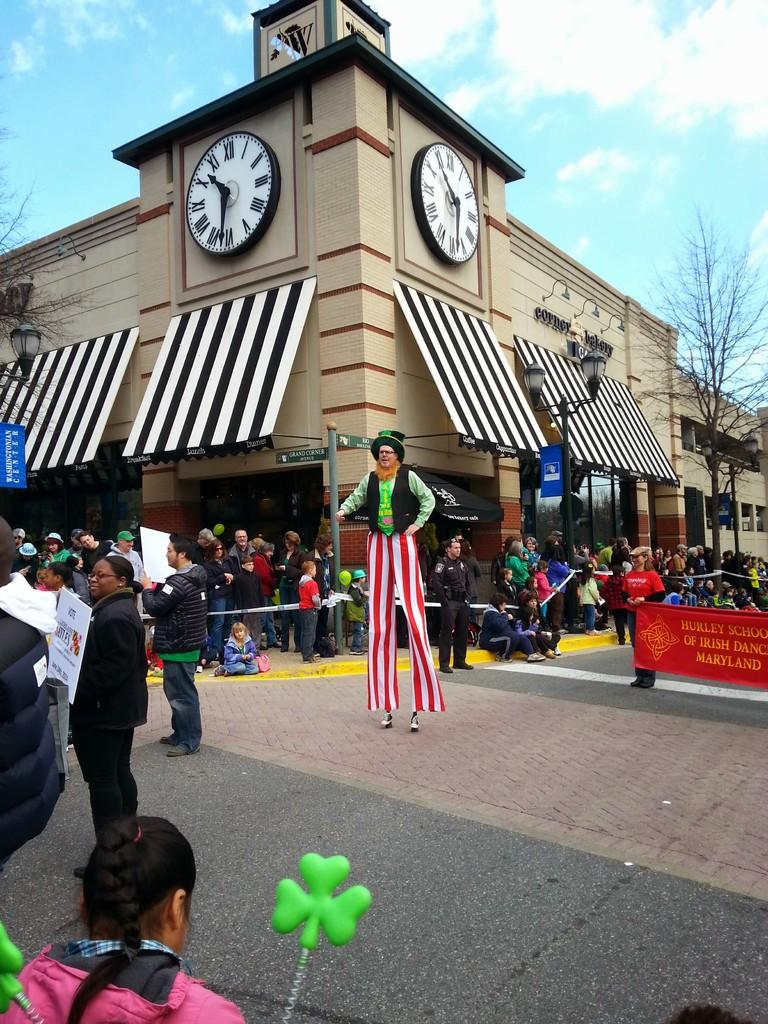What time does the clock show?
Provide a short and direct response. 10:32. 